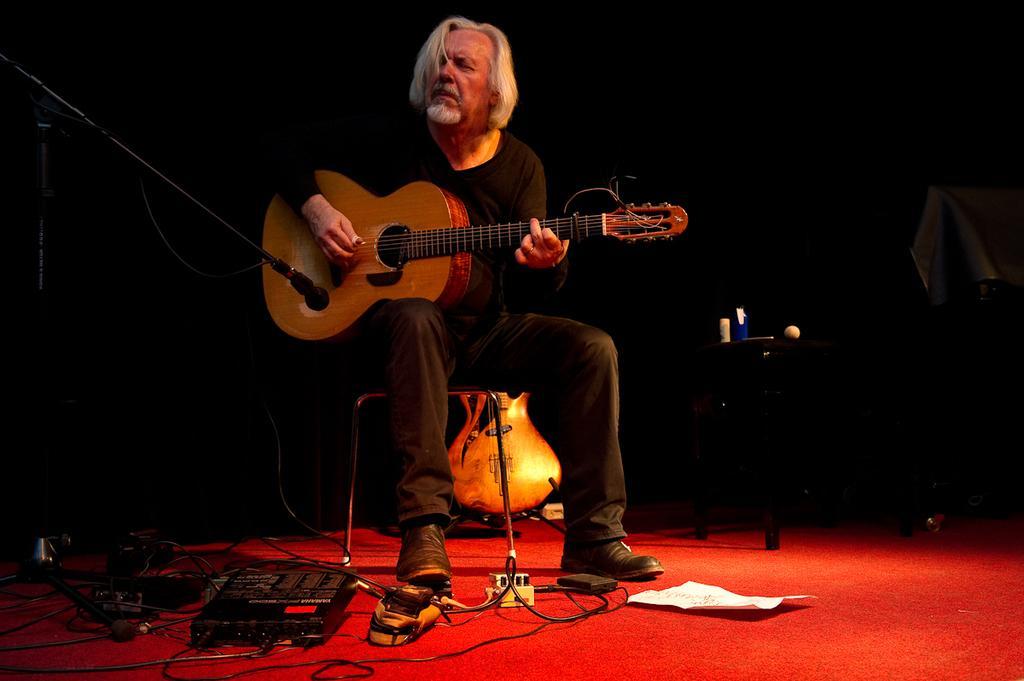Can you describe this image briefly? This man is sitting on a chair and holds a guitar. This is an electronic device with cables. On a floor there is a paper. This is table. Mic with mic holder. 